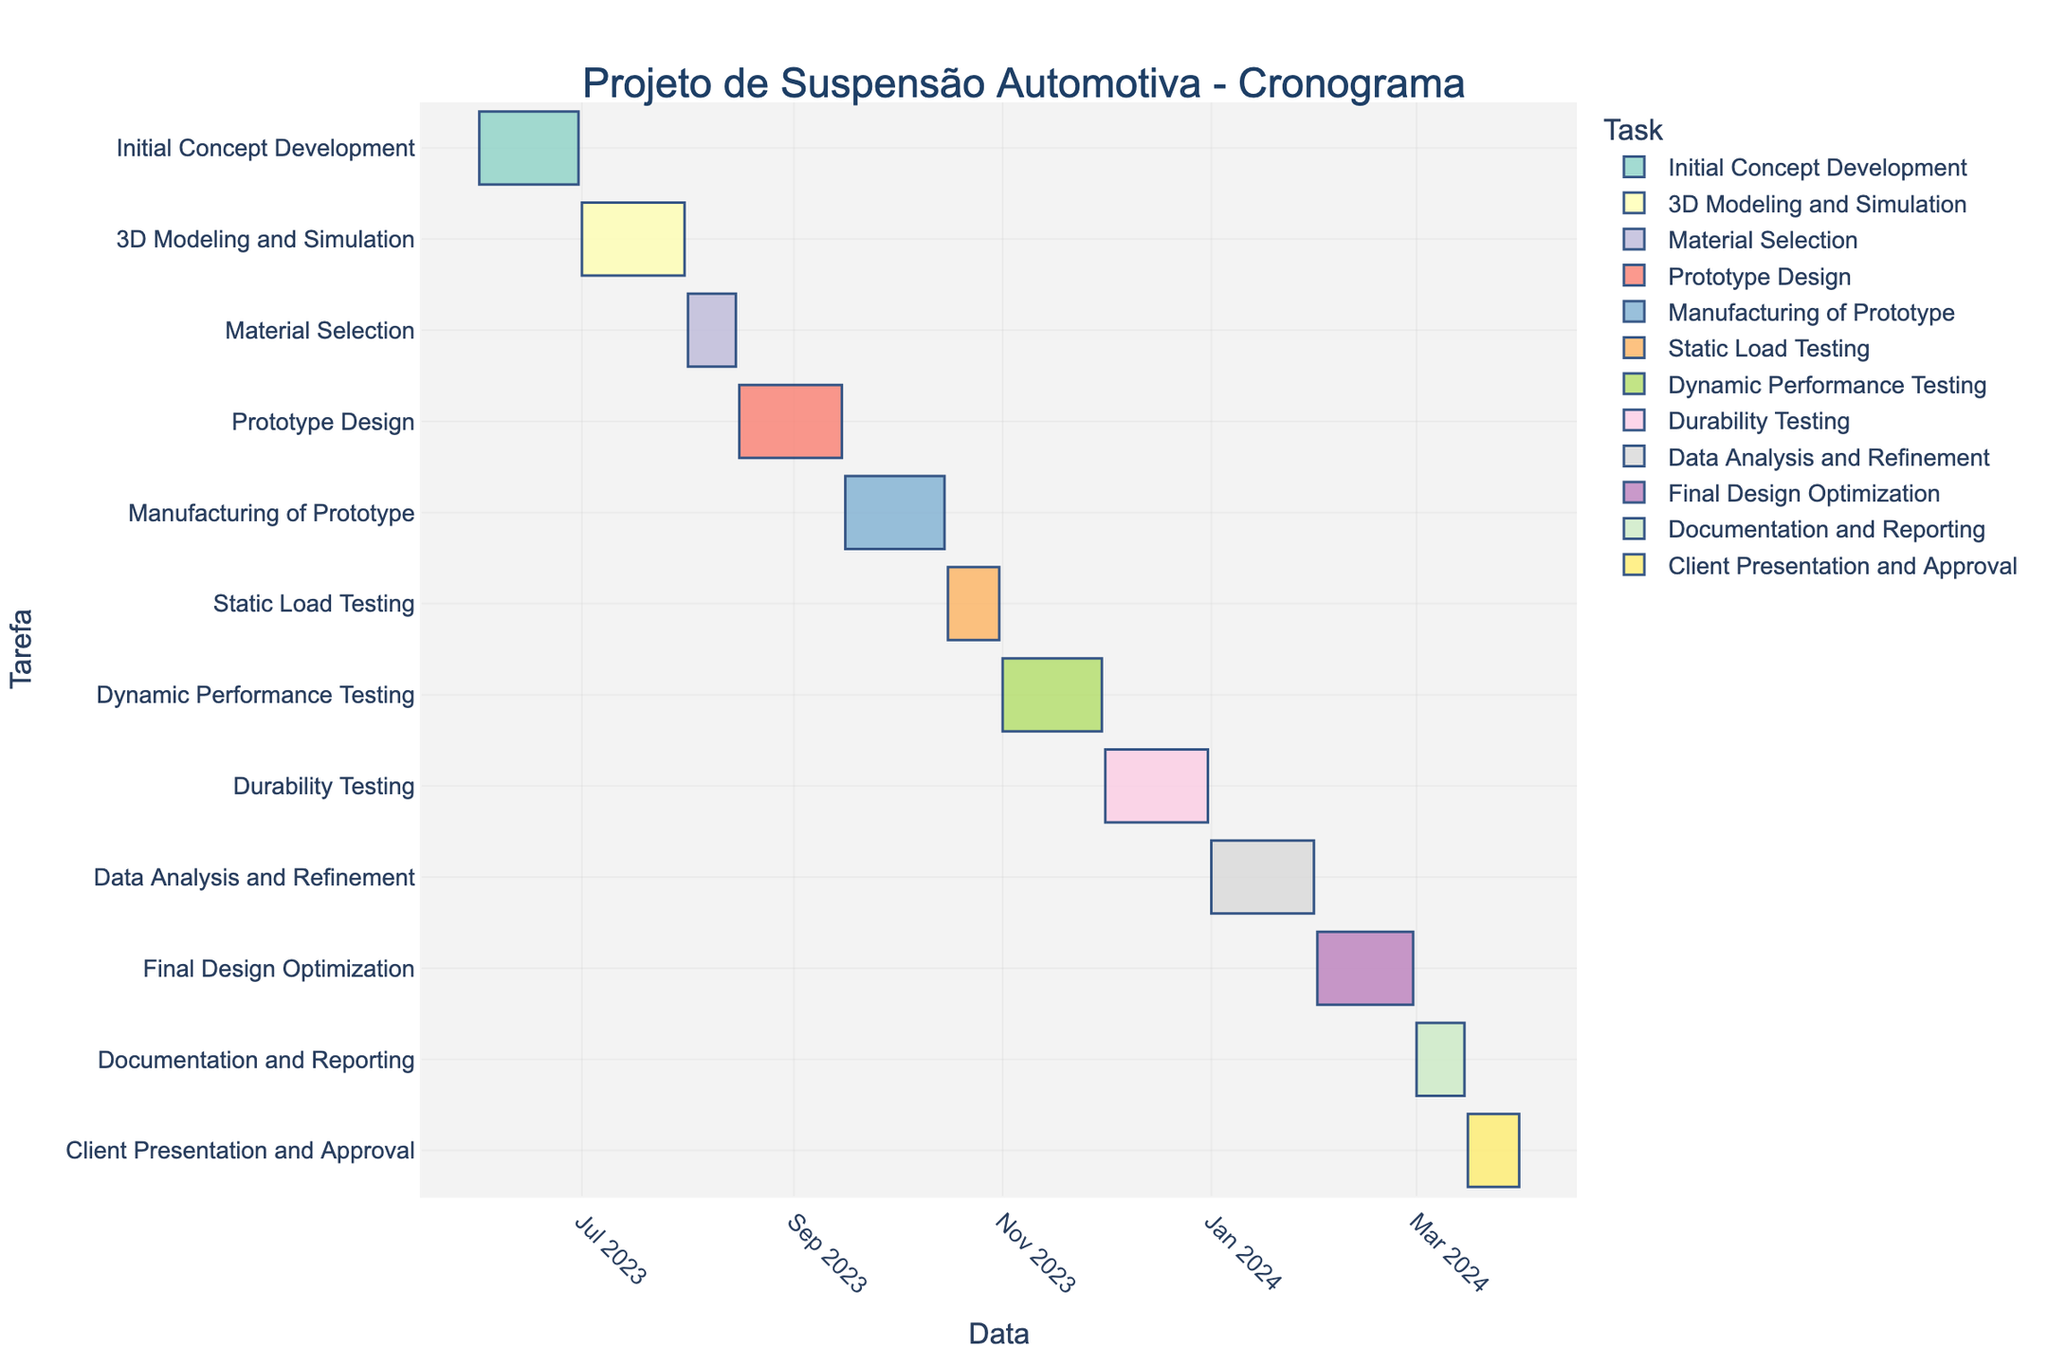What period is covered by the Initial Concept Development phase? According to the Gantt Chart, the Initial Concept Development phase starts on June 1, 2023, and ends on June 30, 2023.
Answer: June 1, 2023, to June 30, 2023 Which phase has the longest duration? By looking at the End Date and Start Date for each task, it is clear that there are several tasks with 31 days duration. Therefore, the tasks "3D Modeling and Simulation", "Durability Testing", and "Data Analysis and Refinement" have the longest durations.
Answer: 3D Modeling and Simulation, Durability Testing, Data Analysis and Refinement When does the Final Design Optimization phase end? According to the Gantt Chart, the Final Design Optimization phase ends on February 29, 2024.
Answer: February 29, 2024 How many phases are there between the start of the project and the end of Static Load Testing? The phases counted from the start to the end of Static Load Testing are Initial Concept Development, 3D Modeling and Simulation, Material Selection, Prototype Design, Manufacturing of Prototype, and Static Load Testing. There are 6 phases in total.
Answer: 6 Which phase directly follows the Prototype Design? The phase that directly follows Prototype Design according to the Gantt Chart is Manufacturing of Prototype.
Answer: Manufacturing of Prototype Compare the durations of Static Load Testing and Dynamic Performance Testing and determine which is longer. Static Load Testing has a duration of 16 days, while Dynamic Performance Testing has a duration of 30 days. Dynamic Performance Testing is longer.
Answer: Dynamic Performance Testing is longer How many total days does the Documentation and Reporting phase take? According to the Gantt Chart, the Documentation and Reporting phase starts on March 1, 2024, and ends on March 15, 2024. This phase takes a total of 15 days.
Answer: 15 days What is the sequence of testing phases? The testing phases in the sequence provided by the Gantt Chart are Static Load Testing, Dynamic Performance Testing, and Durability Testing.
Answer: Static Load Testing, Dynamic Performance Testing, Durability Testing How long does the entire project take from start to finish? The first phase starts on June 1, 2023, and the final phase ends on March 31, 2024. The total duration from start to finish can be calculated as the end date minus the start date including both dates. This is (March 31, 2024 - June 1, 2023) equals approximately 305 days.
Answer: 305 days Which phase has the shortest duration? According to the data, the phase with the shortest duration is Material Selection, which lasts for 15 days.
Answer: Material Selection 